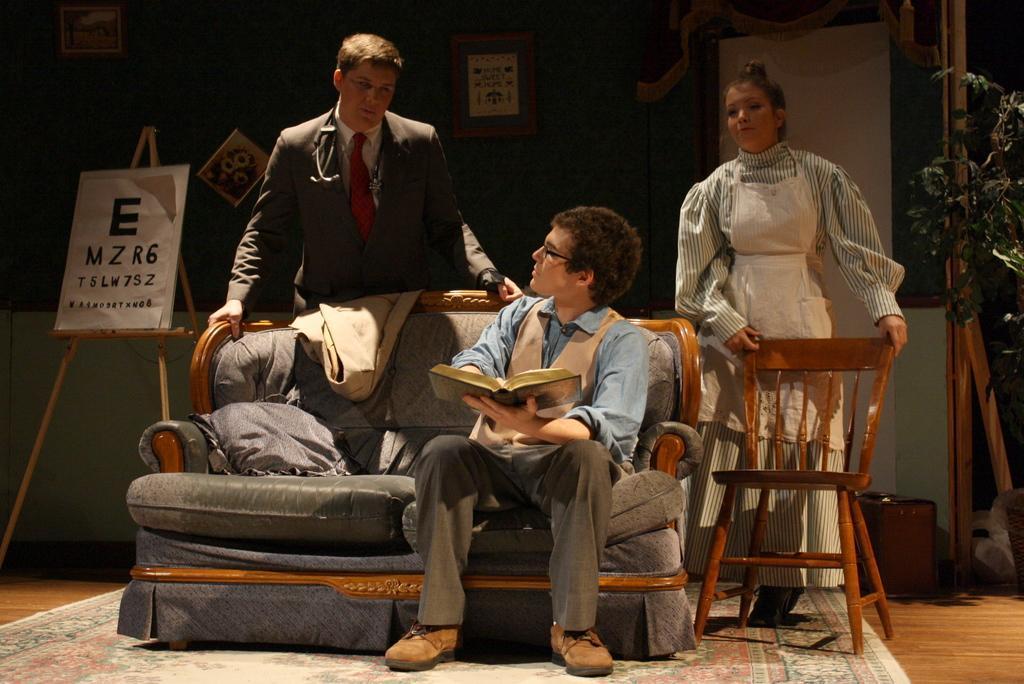Can you describe this image briefly? In this image I see a man who is sitting on the sofa and he is holding a book. I can also see and another man and a women who are standing behind the sofa and there is a chair over here. In the background I see a board on which there is a paper and there are letters written on it and I see the wall on which there are few photo frames and there is a plant over here. 